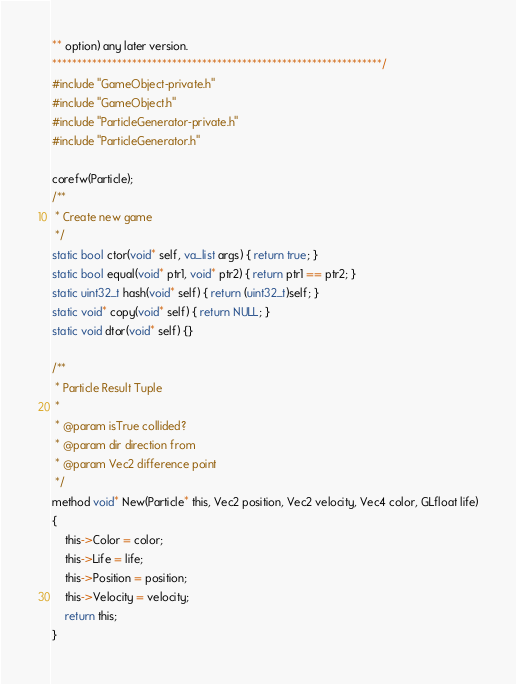Convert code to text. <code><loc_0><loc_0><loc_500><loc_500><_C_>** option) any later version.
******************************************************************/
#include "GameObject-private.h"
#include "GameObject.h"
#include "ParticleGenerator-private.h"
#include "ParticleGenerator.h"

corefw(Particle);
/**
 * Create new game
 */
static bool ctor(void* self, va_list args) { return true; }
static bool equal(void* ptr1, void* ptr2) { return ptr1 == ptr2; }
static uint32_t hash(void* self) { return (uint32_t)self; }
static void* copy(void* self) { return NULL; }
static void dtor(void* self) {}

/**
 * Particle Result Tuple
 * 
 * @param isTrue collided?
 * @param dir direction from
 * @param Vec2 difference point
 */
method void* New(Particle* this, Vec2 position, Vec2 velocity, Vec4 color, GLfloat life)
{
    this->Color = color;
    this->Life = life;
    this->Position = position;
    this->Velocity = velocity;
    return this;
}
</code> 